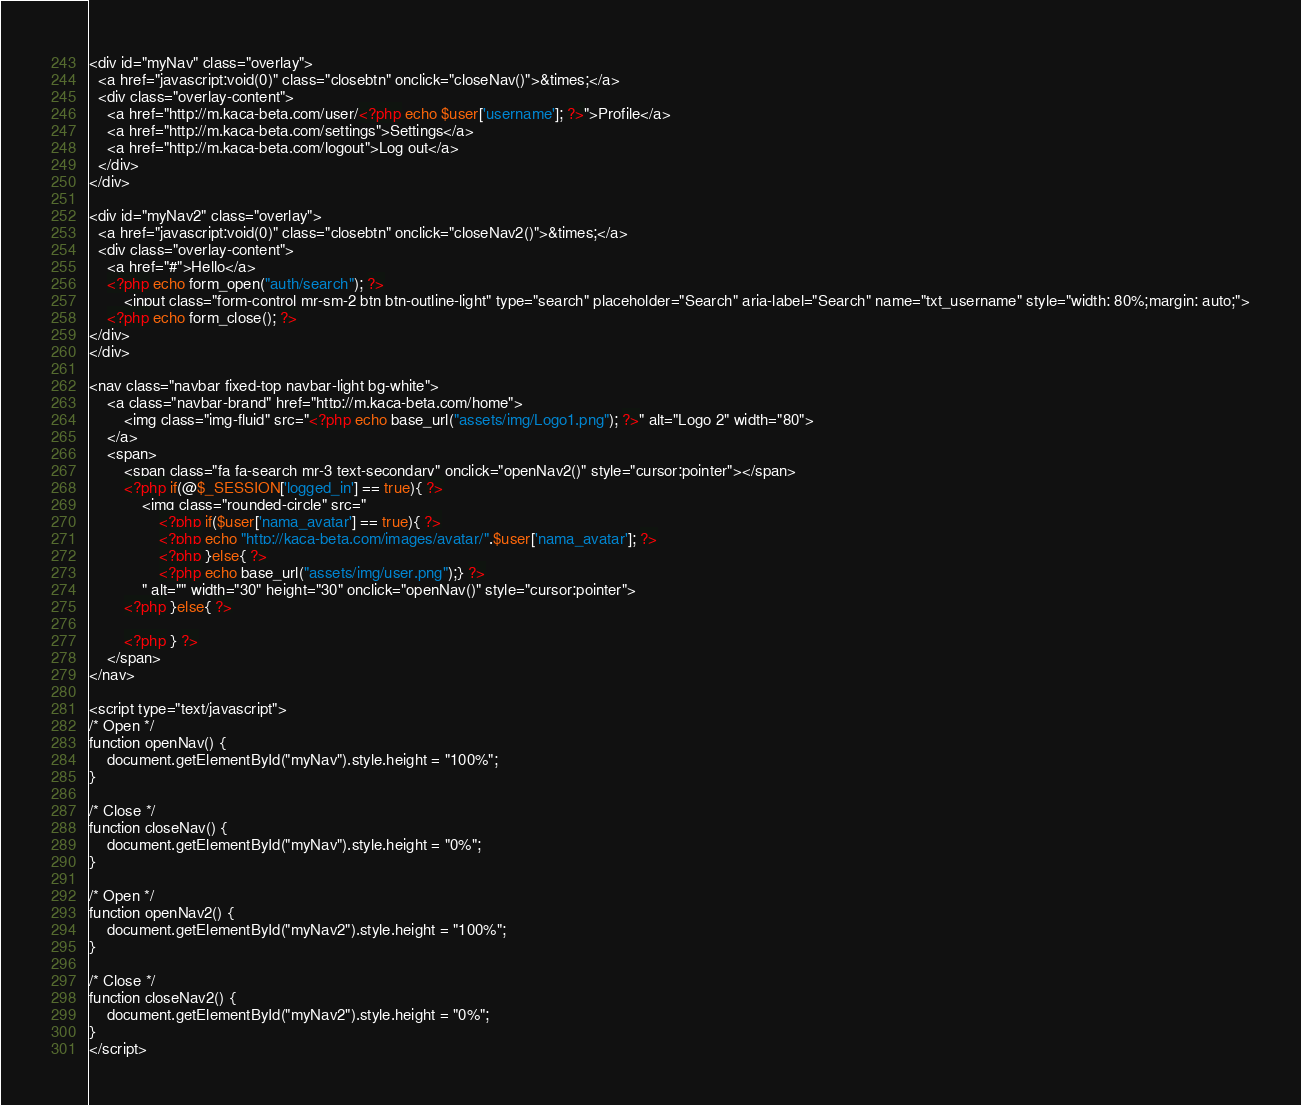<code> <loc_0><loc_0><loc_500><loc_500><_PHP_><div id="myNav" class="overlay">
  <a href="javascript:void(0)" class="closebtn" onclick="closeNav()">&times;</a>
  <div class="overlay-content">
    <a href="http://m.kaca-beta.com/user/<?php echo $user['username']; ?>">Profile</a>
    <a href="http://m.kaca-beta.com/settings">Settings</a>
    <a href="http://m.kaca-beta.com/logout">Log out</a>
  </div>
</div>

<div id="myNav2" class="overlay">
  <a href="javascript:void(0)" class="closebtn" onclick="closeNav2()">&times;</a>
  <div class="overlay-content">
    <a href="#">Hello</a>
    <?php echo form_open("auth/search"); ?>
        <input class="form-control mr-sm-2 btn btn-outline-light" type="search" placeholder="Search" aria-label="Search" name="txt_username" style="width: 80%;margin: auto;">
    <?php echo form_close(); ?>
</div>
</div>

<nav class="navbar fixed-top navbar-light bg-white">
    <a class="navbar-brand" href="http://m.kaca-beta.com/home">
        <img class="img-fluid" src="<?php echo base_url("assets/img/Logo1.png"); ?>" alt="Logo 2" width="80">
    </a>
    <span>
        <span class="fa fa-search mr-3 text-secondary" onclick="openNav2()" style="cursor:pointer"></span>
        <?php if(@$_SESSION['logged_in'] == true){ ?>
            <img class="rounded-circle" src="
                <?php if($user['nama_avatar'] == true){ ?>
                <?php echo "http://kaca-beta.com/images/avatar/".$user['nama_avatar']; ?>
                <?php }else{ ?>
                <?php echo base_url("assets/img/user.png");} ?>
            " alt="" width="30" height="30" onclick="openNav()" style="cursor:pointer">
        <?php }else{ ?>
            
        <?php } ?>
    </span>
</nav>

<script type="text/javascript">
/* Open */
function openNav() {
    document.getElementById("myNav").style.height = "100%";
}

/* Close */
function closeNav() {
    document.getElementById("myNav").style.height = "0%";
}

/* Open */
function openNav2() {
    document.getElementById("myNav2").style.height = "100%";
}

/* Close */
function closeNav2() {
    document.getElementById("myNav2").style.height = "0%";
}
</script></code> 